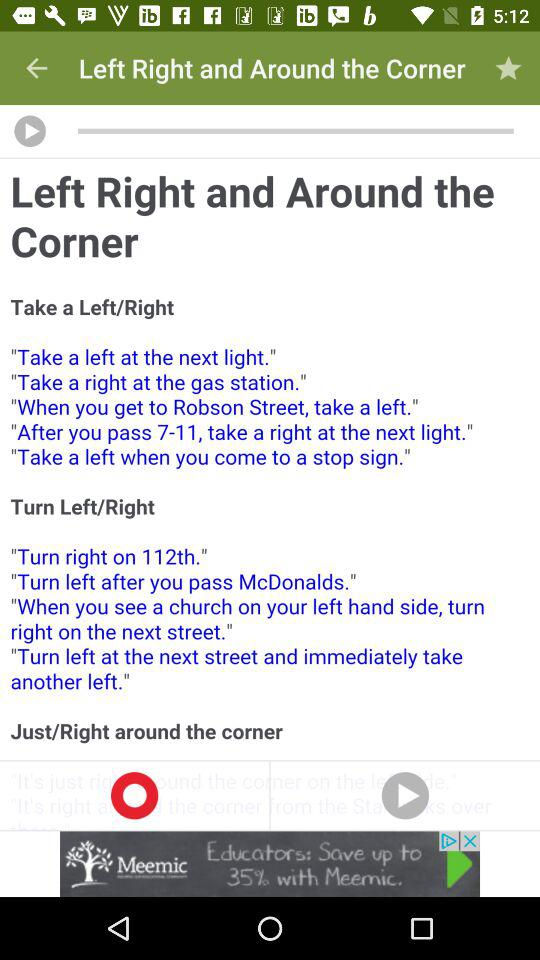How many sentences are there in the 'Turn Left/Right' section?
Answer the question using a single word or phrase. 4 